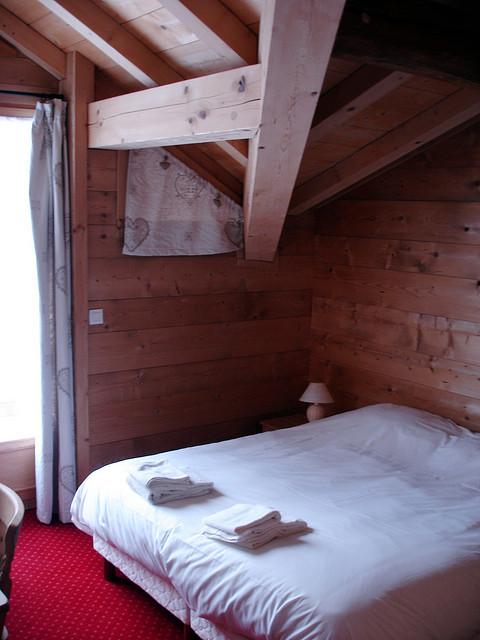What type of fence is in the yard?
Quick response, please. Wooden. What are the white piles at the foot of the bed?
Concise answer only. Towels. Is this indoors?
Quick response, please. Yes. What do people do here?
Quick response, please. Sleep. What kinds of beds are these?
Write a very short answer. Queen. 